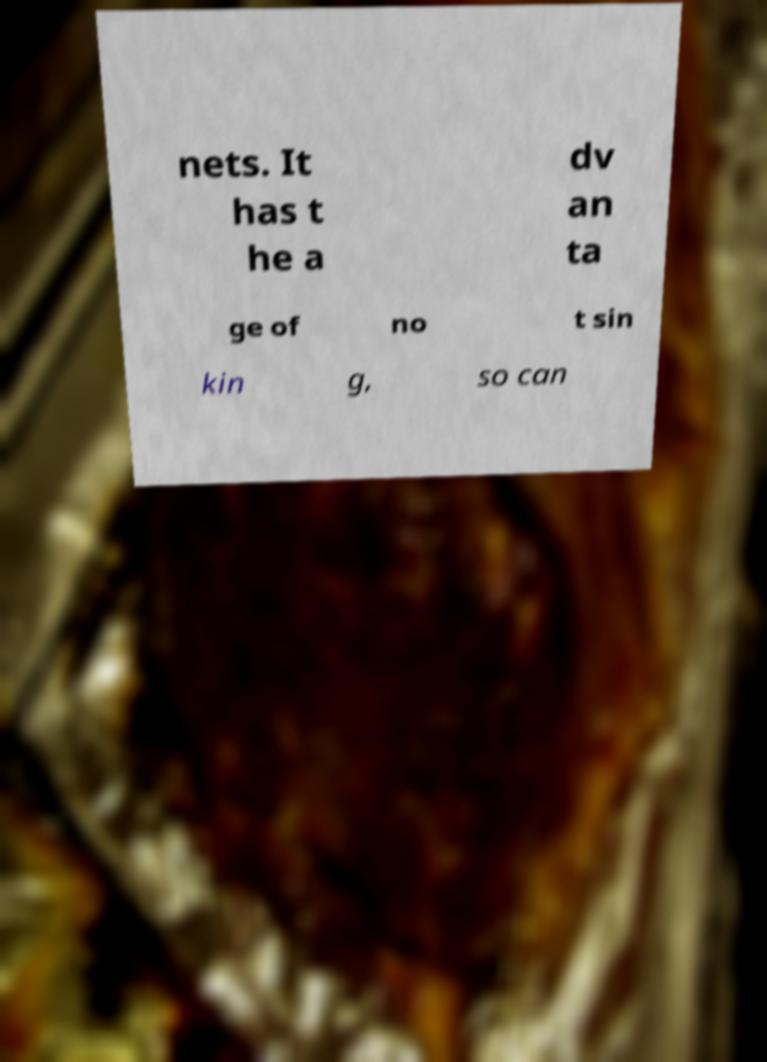Could you assist in decoding the text presented in this image and type it out clearly? nets. It has t he a dv an ta ge of no t sin kin g, so can 